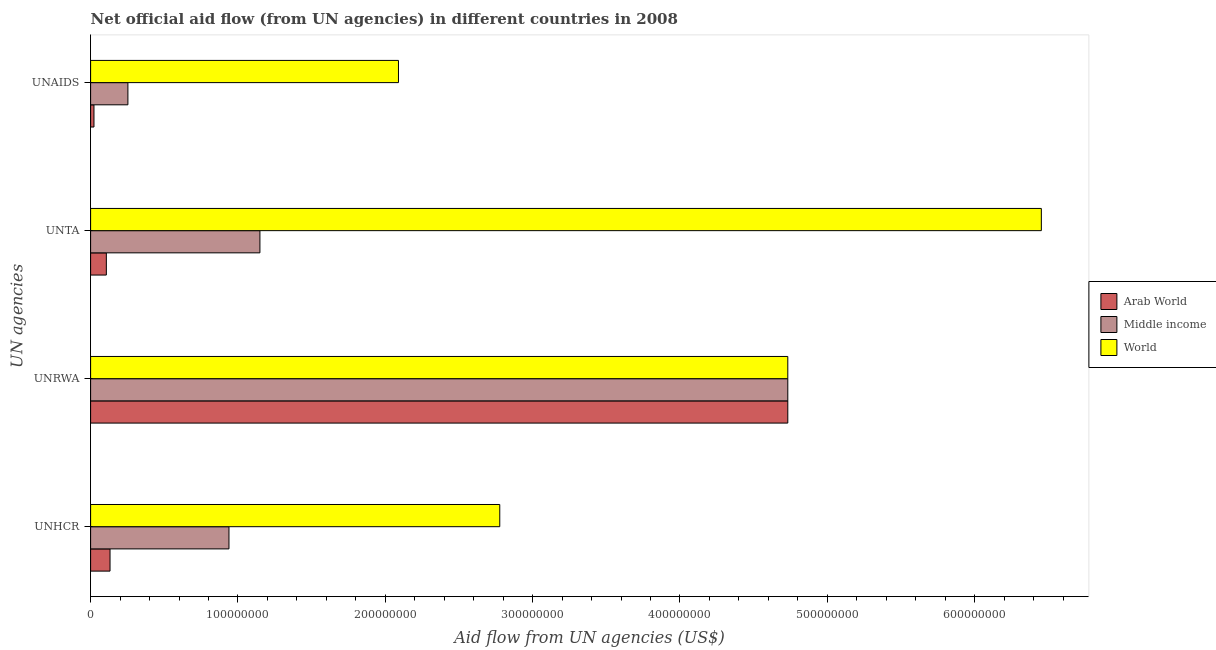How many groups of bars are there?
Give a very brief answer. 4. How many bars are there on the 3rd tick from the top?
Give a very brief answer. 3. What is the label of the 2nd group of bars from the top?
Keep it short and to the point. UNTA. What is the amount of aid given by unrwa in Middle income?
Give a very brief answer. 4.73e+08. Across all countries, what is the maximum amount of aid given by unta?
Offer a terse response. 6.45e+08. Across all countries, what is the minimum amount of aid given by unaids?
Offer a terse response. 2.28e+06. In which country was the amount of aid given by unrwa minimum?
Make the answer very short. Arab World. What is the total amount of aid given by unrwa in the graph?
Offer a terse response. 1.42e+09. What is the difference between the amount of aid given by unaids in Middle income and that in World?
Make the answer very short. -1.84e+08. What is the difference between the amount of aid given by unrwa in Arab World and the amount of aid given by unaids in World?
Give a very brief answer. 2.64e+08. What is the average amount of aid given by unaids per country?
Your answer should be very brief. 7.88e+07. What is the difference between the amount of aid given by unhcr and amount of aid given by unaids in World?
Offer a terse response. 6.88e+07. In how many countries, is the amount of aid given by unhcr greater than 280000000 US$?
Your answer should be compact. 0. What is the ratio of the amount of aid given by unhcr in World to that in Middle income?
Give a very brief answer. 2.96. Is the amount of aid given by unaids in Arab World less than that in World?
Offer a terse response. Yes. What is the difference between the highest and the second highest amount of aid given by unhcr?
Your answer should be compact. 1.84e+08. What is the difference between the highest and the lowest amount of aid given by unta?
Provide a succinct answer. 6.35e+08. What does the 3rd bar from the top in UNRWA represents?
Keep it short and to the point. Arab World. What does the 1st bar from the bottom in UNTA represents?
Provide a succinct answer. Arab World. Is it the case that in every country, the sum of the amount of aid given by unhcr and amount of aid given by unrwa is greater than the amount of aid given by unta?
Give a very brief answer. Yes. What is the difference between two consecutive major ticks on the X-axis?
Ensure brevity in your answer.  1.00e+08. Are the values on the major ticks of X-axis written in scientific E-notation?
Keep it short and to the point. No. Does the graph contain any zero values?
Provide a short and direct response. No. Does the graph contain grids?
Offer a terse response. No. How are the legend labels stacked?
Provide a short and direct response. Vertical. What is the title of the graph?
Ensure brevity in your answer.  Net official aid flow (from UN agencies) in different countries in 2008. What is the label or title of the X-axis?
Offer a very short reply. Aid flow from UN agencies (US$). What is the label or title of the Y-axis?
Your answer should be very brief. UN agencies. What is the Aid flow from UN agencies (US$) in Arab World in UNHCR?
Make the answer very short. 1.32e+07. What is the Aid flow from UN agencies (US$) in Middle income in UNHCR?
Your response must be concise. 9.39e+07. What is the Aid flow from UN agencies (US$) in World in UNHCR?
Give a very brief answer. 2.78e+08. What is the Aid flow from UN agencies (US$) of Arab World in UNRWA?
Your response must be concise. 4.73e+08. What is the Aid flow from UN agencies (US$) of Middle income in UNRWA?
Offer a very short reply. 4.73e+08. What is the Aid flow from UN agencies (US$) of World in UNRWA?
Keep it short and to the point. 4.73e+08. What is the Aid flow from UN agencies (US$) in Arab World in UNTA?
Your answer should be very brief. 1.07e+07. What is the Aid flow from UN agencies (US$) of Middle income in UNTA?
Ensure brevity in your answer.  1.15e+08. What is the Aid flow from UN agencies (US$) in World in UNTA?
Provide a short and direct response. 6.45e+08. What is the Aid flow from UN agencies (US$) in Arab World in UNAIDS?
Keep it short and to the point. 2.28e+06. What is the Aid flow from UN agencies (US$) in Middle income in UNAIDS?
Provide a succinct answer. 2.53e+07. What is the Aid flow from UN agencies (US$) of World in UNAIDS?
Your response must be concise. 2.09e+08. Across all UN agencies, what is the maximum Aid flow from UN agencies (US$) in Arab World?
Offer a very short reply. 4.73e+08. Across all UN agencies, what is the maximum Aid flow from UN agencies (US$) in Middle income?
Keep it short and to the point. 4.73e+08. Across all UN agencies, what is the maximum Aid flow from UN agencies (US$) in World?
Offer a very short reply. 6.45e+08. Across all UN agencies, what is the minimum Aid flow from UN agencies (US$) in Arab World?
Offer a terse response. 2.28e+06. Across all UN agencies, what is the minimum Aid flow from UN agencies (US$) in Middle income?
Keep it short and to the point. 2.53e+07. Across all UN agencies, what is the minimum Aid flow from UN agencies (US$) in World?
Your answer should be compact. 2.09e+08. What is the total Aid flow from UN agencies (US$) in Arab World in the graph?
Your answer should be very brief. 4.99e+08. What is the total Aid flow from UN agencies (US$) in Middle income in the graph?
Offer a terse response. 7.07e+08. What is the total Aid flow from UN agencies (US$) of World in the graph?
Offer a terse response. 1.61e+09. What is the difference between the Aid flow from UN agencies (US$) in Arab World in UNHCR and that in UNRWA?
Your response must be concise. -4.60e+08. What is the difference between the Aid flow from UN agencies (US$) in Middle income in UNHCR and that in UNRWA?
Provide a succinct answer. -3.79e+08. What is the difference between the Aid flow from UN agencies (US$) in World in UNHCR and that in UNRWA?
Your response must be concise. -1.95e+08. What is the difference between the Aid flow from UN agencies (US$) of Arab World in UNHCR and that in UNTA?
Provide a succinct answer. 2.50e+06. What is the difference between the Aid flow from UN agencies (US$) of Middle income in UNHCR and that in UNTA?
Your answer should be very brief. -2.10e+07. What is the difference between the Aid flow from UN agencies (US$) of World in UNHCR and that in UNTA?
Offer a terse response. -3.68e+08. What is the difference between the Aid flow from UN agencies (US$) of Arab World in UNHCR and that in UNAIDS?
Provide a short and direct response. 1.09e+07. What is the difference between the Aid flow from UN agencies (US$) of Middle income in UNHCR and that in UNAIDS?
Provide a short and direct response. 6.86e+07. What is the difference between the Aid flow from UN agencies (US$) of World in UNHCR and that in UNAIDS?
Provide a succinct answer. 6.88e+07. What is the difference between the Aid flow from UN agencies (US$) in Arab World in UNRWA and that in UNTA?
Offer a very short reply. 4.63e+08. What is the difference between the Aid flow from UN agencies (US$) in Middle income in UNRWA and that in UNTA?
Give a very brief answer. 3.58e+08. What is the difference between the Aid flow from UN agencies (US$) of World in UNRWA and that in UNTA?
Your answer should be compact. -1.72e+08. What is the difference between the Aid flow from UN agencies (US$) of Arab World in UNRWA and that in UNAIDS?
Your answer should be compact. 4.71e+08. What is the difference between the Aid flow from UN agencies (US$) in Middle income in UNRWA and that in UNAIDS?
Offer a terse response. 4.48e+08. What is the difference between the Aid flow from UN agencies (US$) in World in UNRWA and that in UNAIDS?
Your answer should be compact. 2.64e+08. What is the difference between the Aid flow from UN agencies (US$) in Arab World in UNTA and that in UNAIDS?
Make the answer very short. 8.40e+06. What is the difference between the Aid flow from UN agencies (US$) of Middle income in UNTA and that in UNAIDS?
Ensure brevity in your answer.  8.96e+07. What is the difference between the Aid flow from UN agencies (US$) in World in UNTA and that in UNAIDS?
Provide a succinct answer. 4.36e+08. What is the difference between the Aid flow from UN agencies (US$) of Arab World in UNHCR and the Aid flow from UN agencies (US$) of Middle income in UNRWA?
Provide a short and direct response. -4.60e+08. What is the difference between the Aid flow from UN agencies (US$) of Arab World in UNHCR and the Aid flow from UN agencies (US$) of World in UNRWA?
Provide a succinct answer. -4.60e+08. What is the difference between the Aid flow from UN agencies (US$) in Middle income in UNHCR and the Aid flow from UN agencies (US$) in World in UNRWA?
Your answer should be compact. -3.79e+08. What is the difference between the Aid flow from UN agencies (US$) in Arab World in UNHCR and the Aid flow from UN agencies (US$) in Middle income in UNTA?
Offer a terse response. -1.02e+08. What is the difference between the Aid flow from UN agencies (US$) of Arab World in UNHCR and the Aid flow from UN agencies (US$) of World in UNTA?
Give a very brief answer. -6.32e+08. What is the difference between the Aid flow from UN agencies (US$) of Middle income in UNHCR and the Aid flow from UN agencies (US$) of World in UNTA?
Provide a short and direct response. -5.51e+08. What is the difference between the Aid flow from UN agencies (US$) of Arab World in UNHCR and the Aid flow from UN agencies (US$) of Middle income in UNAIDS?
Your answer should be compact. -1.21e+07. What is the difference between the Aid flow from UN agencies (US$) in Arab World in UNHCR and the Aid flow from UN agencies (US$) in World in UNAIDS?
Offer a terse response. -1.96e+08. What is the difference between the Aid flow from UN agencies (US$) of Middle income in UNHCR and the Aid flow from UN agencies (US$) of World in UNAIDS?
Provide a short and direct response. -1.15e+08. What is the difference between the Aid flow from UN agencies (US$) of Arab World in UNRWA and the Aid flow from UN agencies (US$) of Middle income in UNTA?
Offer a very short reply. 3.58e+08. What is the difference between the Aid flow from UN agencies (US$) in Arab World in UNRWA and the Aid flow from UN agencies (US$) in World in UNTA?
Your answer should be very brief. -1.72e+08. What is the difference between the Aid flow from UN agencies (US$) of Middle income in UNRWA and the Aid flow from UN agencies (US$) of World in UNTA?
Your answer should be compact. -1.72e+08. What is the difference between the Aid flow from UN agencies (US$) of Arab World in UNRWA and the Aid flow from UN agencies (US$) of Middle income in UNAIDS?
Your answer should be compact. 4.48e+08. What is the difference between the Aid flow from UN agencies (US$) of Arab World in UNRWA and the Aid flow from UN agencies (US$) of World in UNAIDS?
Make the answer very short. 2.64e+08. What is the difference between the Aid flow from UN agencies (US$) in Middle income in UNRWA and the Aid flow from UN agencies (US$) in World in UNAIDS?
Make the answer very short. 2.64e+08. What is the difference between the Aid flow from UN agencies (US$) of Arab World in UNTA and the Aid flow from UN agencies (US$) of Middle income in UNAIDS?
Provide a short and direct response. -1.46e+07. What is the difference between the Aid flow from UN agencies (US$) of Arab World in UNTA and the Aid flow from UN agencies (US$) of World in UNAIDS?
Give a very brief answer. -1.98e+08. What is the difference between the Aid flow from UN agencies (US$) of Middle income in UNTA and the Aid flow from UN agencies (US$) of World in UNAIDS?
Your answer should be compact. -9.40e+07. What is the average Aid flow from UN agencies (US$) of Arab World per UN agencies?
Your answer should be very brief. 1.25e+08. What is the average Aid flow from UN agencies (US$) of Middle income per UN agencies?
Offer a very short reply. 1.77e+08. What is the average Aid flow from UN agencies (US$) in World per UN agencies?
Give a very brief answer. 4.01e+08. What is the difference between the Aid flow from UN agencies (US$) in Arab World and Aid flow from UN agencies (US$) in Middle income in UNHCR?
Offer a terse response. -8.07e+07. What is the difference between the Aid flow from UN agencies (US$) of Arab World and Aid flow from UN agencies (US$) of World in UNHCR?
Make the answer very short. -2.65e+08. What is the difference between the Aid flow from UN agencies (US$) in Middle income and Aid flow from UN agencies (US$) in World in UNHCR?
Provide a succinct answer. -1.84e+08. What is the difference between the Aid flow from UN agencies (US$) of Arab World and Aid flow from UN agencies (US$) of Middle income in UNTA?
Keep it short and to the point. -1.04e+08. What is the difference between the Aid flow from UN agencies (US$) in Arab World and Aid flow from UN agencies (US$) in World in UNTA?
Your response must be concise. -6.35e+08. What is the difference between the Aid flow from UN agencies (US$) of Middle income and Aid flow from UN agencies (US$) of World in UNTA?
Provide a succinct answer. -5.30e+08. What is the difference between the Aid flow from UN agencies (US$) of Arab World and Aid flow from UN agencies (US$) of Middle income in UNAIDS?
Offer a very short reply. -2.30e+07. What is the difference between the Aid flow from UN agencies (US$) of Arab World and Aid flow from UN agencies (US$) of World in UNAIDS?
Provide a short and direct response. -2.07e+08. What is the difference between the Aid flow from UN agencies (US$) in Middle income and Aid flow from UN agencies (US$) in World in UNAIDS?
Give a very brief answer. -1.84e+08. What is the ratio of the Aid flow from UN agencies (US$) in Arab World in UNHCR to that in UNRWA?
Offer a terse response. 0.03. What is the ratio of the Aid flow from UN agencies (US$) of Middle income in UNHCR to that in UNRWA?
Offer a very short reply. 0.2. What is the ratio of the Aid flow from UN agencies (US$) of World in UNHCR to that in UNRWA?
Give a very brief answer. 0.59. What is the ratio of the Aid flow from UN agencies (US$) of Arab World in UNHCR to that in UNTA?
Make the answer very short. 1.23. What is the ratio of the Aid flow from UN agencies (US$) of Middle income in UNHCR to that in UNTA?
Keep it short and to the point. 0.82. What is the ratio of the Aid flow from UN agencies (US$) in World in UNHCR to that in UNTA?
Provide a short and direct response. 0.43. What is the ratio of the Aid flow from UN agencies (US$) of Arab World in UNHCR to that in UNAIDS?
Your answer should be compact. 5.78. What is the ratio of the Aid flow from UN agencies (US$) of Middle income in UNHCR to that in UNAIDS?
Provide a short and direct response. 3.71. What is the ratio of the Aid flow from UN agencies (US$) in World in UNHCR to that in UNAIDS?
Offer a terse response. 1.33. What is the ratio of the Aid flow from UN agencies (US$) in Arab World in UNRWA to that in UNTA?
Keep it short and to the point. 44.31. What is the ratio of the Aid flow from UN agencies (US$) in Middle income in UNRWA to that in UNTA?
Your answer should be compact. 4.12. What is the ratio of the Aid flow from UN agencies (US$) of World in UNRWA to that in UNTA?
Keep it short and to the point. 0.73. What is the ratio of the Aid flow from UN agencies (US$) in Arab World in UNRWA to that in UNAIDS?
Provide a succinct answer. 207.54. What is the ratio of the Aid flow from UN agencies (US$) of Middle income in UNRWA to that in UNAIDS?
Ensure brevity in your answer.  18.69. What is the ratio of the Aid flow from UN agencies (US$) of World in UNRWA to that in UNAIDS?
Keep it short and to the point. 2.26. What is the ratio of the Aid flow from UN agencies (US$) of Arab World in UNTA to that in UNAIDS?
Your answer should be compact. 4.68. What is the ratio of the Aid flow from UN agencies (US$) of Middle income in UNTA to that in UNAIDS?
Give a very brief answer. 4.54. What is the ratio of the Aid flow from UN agencies (US$) in World in UNTA to that in UNAIDS?
Provide a succinct answer. 3.09. What is the difference between the highest and the second highest Aid flow from UN agencies (US$) in Arab World?
Provide a short and direct response. 4.60e+08. What is the difference between the highest and the second highest Aid flow from UN agencies (US$) of Middle income?
Your answer should be compact. 3.58e+08. What is the difference between the highest and the second highest Aid flow from UN agencies (US$) in World?
Provide a short and direct response. 1.72e+08. What is the difference between the highest and the lowest Aid flow from UN agencies (US$) in Arab World?
Offer a very short reply. 4.71e+08. What is the difference between the highest and the lowest Aid flow from UN agencies (US$) in Middle income?
Offer a very short reply. 4.48e+08. What is the difference between the highest and the lowest Aid flow from UN agencies (US$) of World?
Provide a succinct answer. 4.36e+08. 